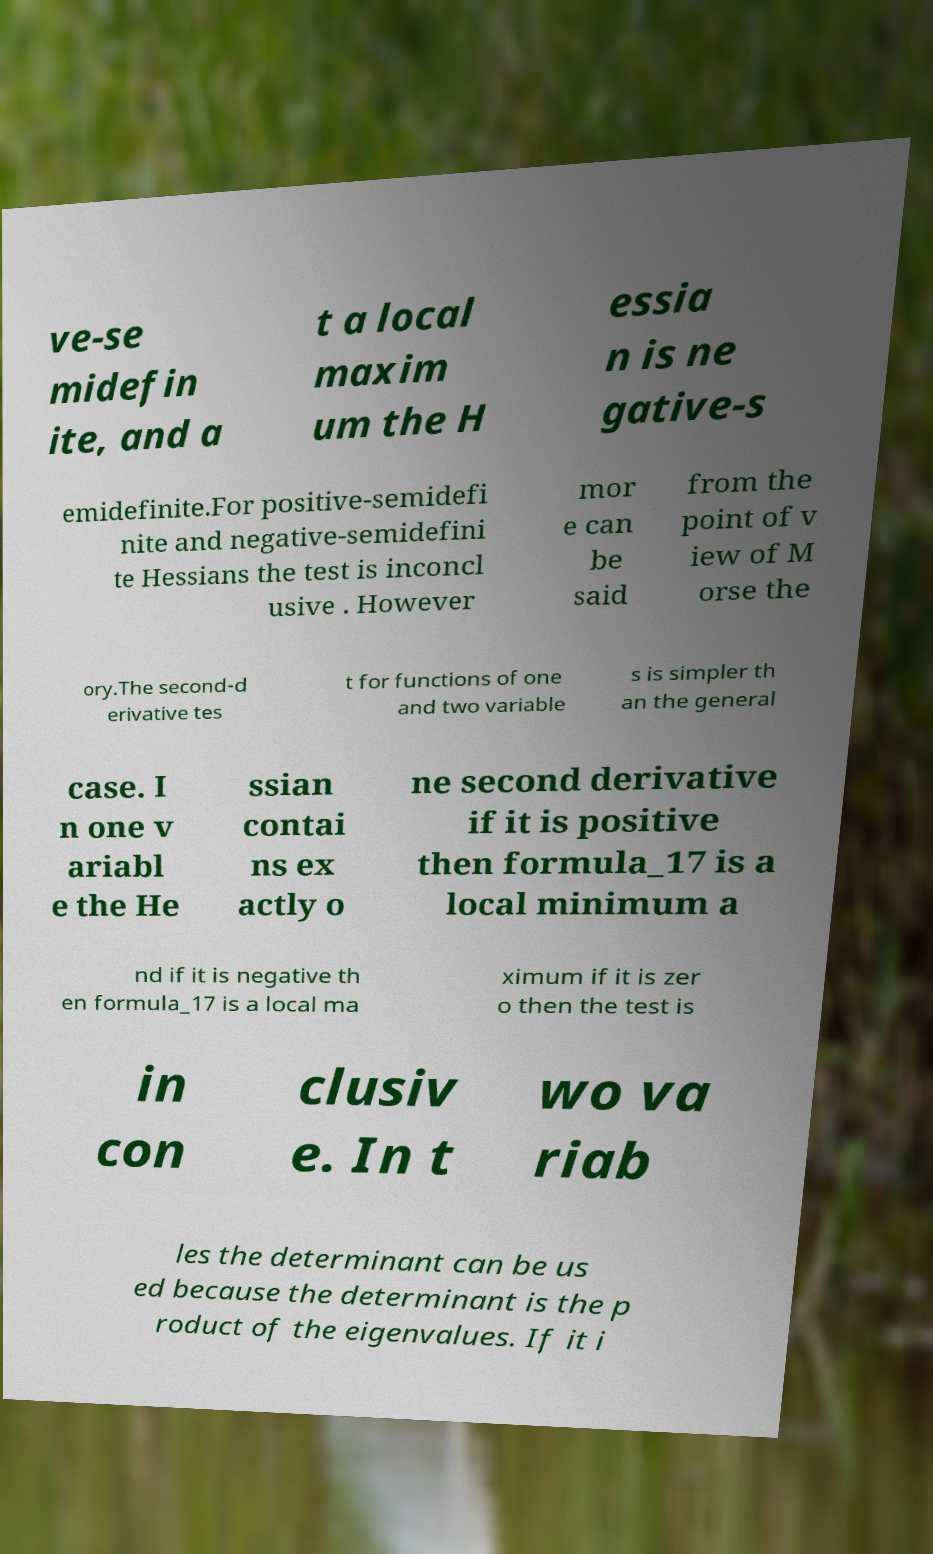What messages or text are displayed in this image? I need them in a readable, typed format. ve-se midefin ite, and a t a local maxim um the H essia n is ne gative-s emidefinite.For positive-semidefi nite and negative-semidefini te Hessians the test is inconcl usive . However mor e can be said from the point of v iew of M orse the ory.The second-d erivative tes t for functions of one and two variable s is simpler th an the general case. I n one v ariabl e the He ssian contai ns ex actly o ne second derivative if it is positive then formula_17 is a local minimum a nd if it is negative th en formula_17 is a local ma ximum if it is zer o then the test is in con clusiv e. In t wo va riab les the determinant can be us ed because the determinant is the p roduct of the eigenvalues. If it i 